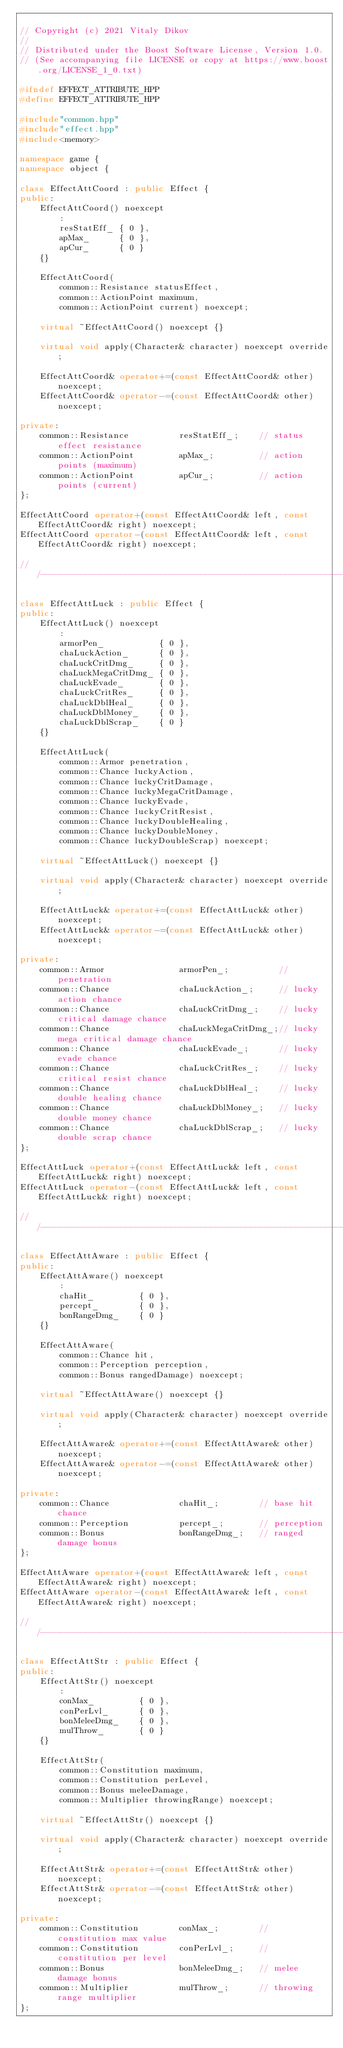<code> <loc_0><loc_0><loc_500><loc_500><_C++_>
// Copyright (c) 2021 Vitaly Dikov
// 
// Distributed under the Boost Software License, Version 1.0.
// (See accompanying file LICENSE or copy at https://www.boost.org/LICENSE_1_0.txt)

#ifndef EFFECT_ATTRIBUTE_HPP
#define EFFECT_ATTRIBUTE_HPP

#include"common.hpp"
#include"effect.hpp"
#include<memory>

namespace game {
namespace object {

class EffectAttCoord : public Effect {
public:
    EffectAttCoord() noexcept
        :
        resStatEff_ { 0 },
        apMax_      { 0 },
        apCur_      { 0 }
    {}

    EffectAttCoord(
        common::Resistance statusEffect,
        common::ActionPoint maximum,
        common::ActionPoint current) noexcept;

    virtual ~EffectAttCoord() noexcept {}

    virtual void apply(Character& character) noexcept override;

    EffectAttCoord& operator+=(const EffectAttCoord& other) noexcept;
    EffectAttCoord& operator-=(const EffectAttCoord& other) noexcept;

private:
    common::Resistance          resStatEff_;    // status effect resistance
    common::ActionPoint         apMax_;         // action points (maximum)
    common::ActionPoint         apCur_;         // action points (current)
};

EffectAttCoord operator+(const EffectAttCoord& left, const EffectAttCoord& right) noexcept;
EffectAttCoord operator-(const EffectAttCoord& left, const EffectAttCoord& right) noexcept;

///------------------------------------------------------------------------------------------------

class EffectAttLuck : public Effect {
public:
    EffectAttLuck() noexcept
        :
        armorPen_           { 0 },
        chaLuckAction_      { 0 },
        chaLuckCritDmg_     { 0 },
        chaLuckMegaCritDmg_ { 0 },
        chaLuckEvade_       { 0 },
        chaLuckCritRes_     { 0 },
        chaLuckDblHeal_     { 0 },
        chaLuckDblMoney_    { 0 },
        chaLuckDblScrap_    { 0 }
    {}

    EffectAttLuck(
        common::Armor penetration,
        common::Chance luckyAction,
        common::Chance luckyCritDamage,
        common::Chance luckyMegaCritDamage,
        common::Chance luckyEvade,
        common::Chance luckyCritResist,
        common::Chance luckyDoubleHealing,
        common::Chance luckyDoubleMoney,
        common::Chance luckyDoubleScrap) noexcept;

    virtual ~EffectAttLuck() noexcept {}

    virtual void apply(Character& character) noexcept override;

    EffectAttLuck& operator+=(const EffectAttLuck& other) noexcept;
    EffectAttLuck& operator-=(const EffectAttLuck& other) noexcept;

private:
    common::Armor               armorPen_;          // penetration
    common::Chance              chaLuckAction_;     // lucky action chance
    common::Chance              chaLuckCritDmg_;    // lucky critical damage chance
    common::Chance              chaLuckMegaCritDmg_;// lucky mega critical damage chance
    common::Chance              chaLuckEvade_;      // lucky evade chance
    common::Chance              chaLuckCritRes_;    // lucky critical resist chance
    common::Chance              chaLuckDblHeal_;    // lucky double healing chance
    common::Chance              chaLuckDblMoney_;   // lucky double money chance
    common::Chance              chaLuckDblScrap_;   // lucky double scrap chance
};

EffectAttLuck operator+(const EffectAttLuck& left, const EffectAttLuck& right) noexcept;
EffectAttLuck operator-(const EffectAttLuck& left, const EffectAttLuck& right) noexcept;

///------------------------------------------------------------------------------------------------

class EffectAttAware : public Effect {
public:
    EffectAttAware() noexcept
        :
        chaHit_         { 0 },
        percept_        { 0 },
        bonRangeDmg_    { 0 }
    {}

    EffectAttAware(
        common::Chance hit,
        common::Perception perception,
        common::Bonus rangedDamage) noexcept;

    virtual ~EffectAttAware() noexcept {}

    virtual void apply(Character& character) noexcept override;

    EffectAttAware& operator+=(const EffectAttAware& other) noexcept;
    EffectAttAware& operator-=(const EffectAttAware& other) noexcept;

private:
    common::Chance              chaHit_;        // base hit chance
    common::Perception          percept_;       // perception
    common::Bonus               bonRangeDmg_;   // ranged damage bonus
};

EffectAttAware operator+(const EffectAttAware& left, const EffectAttAware& right) noexcept;
EffectAttAware operator-(const EffectAttAware& left, const EffectAttAware& right) noexcept;

///------------------------------------------------------------------------------------------------

class EffectAttStr : public Effect {
public:
    EffectAttStr() noexcept
        :
        conMax_         { 0 },
        conPerLvl_      { 0 },
        bonMeleeDmg_    { 0 },
        mulThrow_       { 0 }
    {}

    EffectAttStr(
        common::Constitution maximum,
        common::Constitution perLevel,
        common::Bonus meleeDamage,
        common::Multiplier throwingRange) noexcept;

    virtual ~EffectAttStr() noexcept {}

    virtual void apply(Character& character) noexcept override;

    EffectAttStr& operator+=(const EffectAttStr& other) noexcept;
    EffectAttStr& operator-=(const EffectAttStr& other) noexcept;

private:
    common::Constitution        conMax_;        // constitution max value
    common::Constitution        conPerLvl_;     // constitution per level
    common::Bonus               bonMeleeDmg_;   // melee damage bonus
    common::Multiplier          mulThrow_;      // throwing range multiplier
};
</code> 